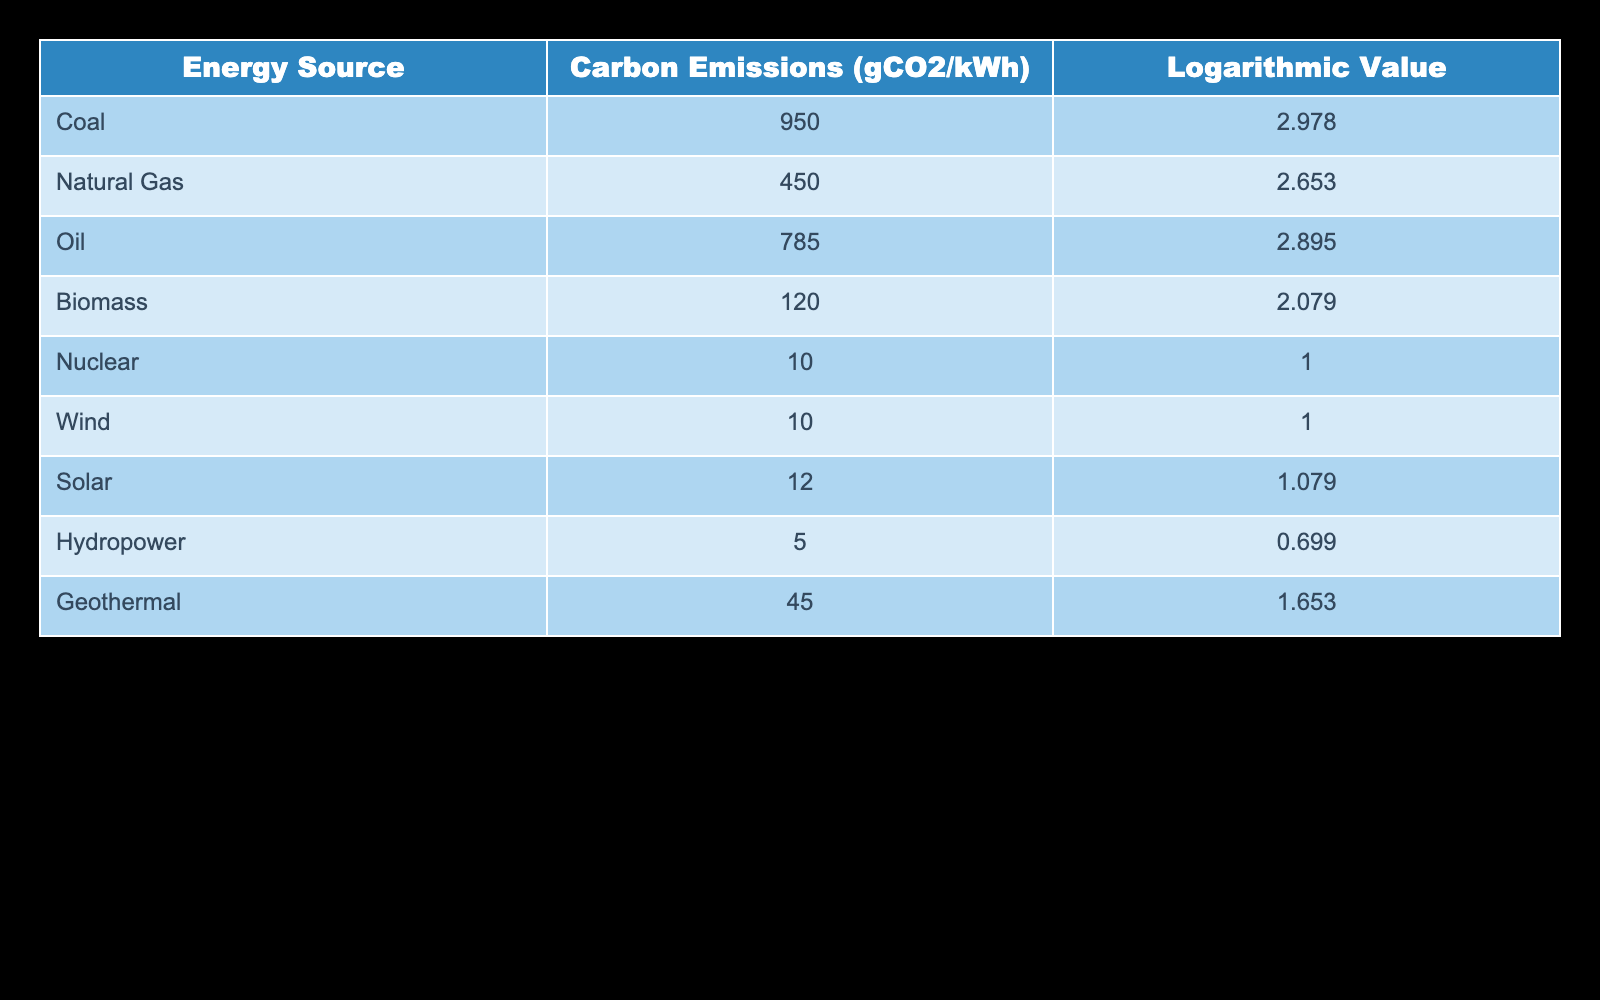What is the carbon emission value for Natural Gas? The table shows the carbon emissions for each energy source. For Natural Gas, the corresponding value is found directly in the "Carbon Emissions (gCO2/kWh)" column. The value for Natural Gas is 450 gCO2/kWh.
Answer: 450 gCO2/kWh Which energy source has the highest carbon emissions? By comparing the carbon emission values listed in the table, Coal has the highest value at 950 gCO2/kWh, as it is greater than the values of all other energy sources.
Answer: Coal What is the difference in carbon emissions between Coal and Biomass? To find the difference, subtract the carbon emissions of Biomass from Coal. Coal has 950 gCO2/kWh, and Biomass has 120 gCO2/kWh. The difference is calculated as 950 - 120 = 830 gCO2/kWh.
Answer: 830 gCO2/kWh Is the carbon emission for Solar lower than that for Oil? According to the table, Solar has 12 gCO2/kWh and Oil has 785 gCO2/kWh. Since 12 is less than 785, the statement is true: Solar's carbon emission is lower than that of Oil.
Answer: Yes What is the average carbon emission value across all the listed energy sources? First, sum the carbon emissions of all energy sources: 950 (Coal) + 450 (Natural Gas) + 785 (Oil) + 120 (Biomass) + 10 (Nuclear) + 10 (Wind) + 12 (Solar) + 5 (Hydropower) + 45 (Geothermal) = 2397 gCO2/kWh. Then, divide by the number of sources (9): 2397 / 9 = 266.33 gCO2/kWh.
Answer: 266.33 gCO2/kWh How many energy sources have carbon emissions less than 100 gCO2/kWh? Looking through the table, only Nuclear (10 gCO2/kWh), Wind (10 gCO2/kWh), and Hydropower (5 gCO2/kWh) fall below 100 gCO2/kWh. Thus, there are three energy sources meeting this criterion.
Answer: 3 Which source has a logarithmic value greater than 2.5? The logarithmic values are provided in the table. The values greater than 2.5 are for Coal (2.978), Oil (2.895), and Natural Gas (2.653). Therefore, Coal, Oil, and Natural Gas have logarithmic values greater than 2.5.
Answer: Coal, Oil, Natural Gas Is Nuclear energy the most environmentally friendly option based on carbon emissions? Since Nuclear has the lowest carbon emissions listed at 10 gCO2/kWh, which is less than that of any other energy source in the table, it is true to say that Nuclear energy is the most environmentally friendly option.
Answer: Yes 